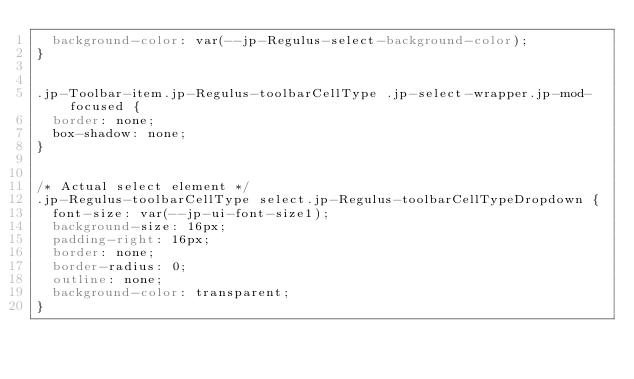<code> <loc_0><loc_0><loc_500><loc_500><_CSS_>  background-color: var(--jp-Regulus-select-background-color);
}


.jp-Toolbar-item.jp-Regulus-toolbarCellType .jp-select-wrapper.jp-mod-focused {
  border: none;
  box-shadow: none;
}


/* Actual select element */
.jp-Regulus-toolbarCellType select.jp-Regulus-toolbarCellTypeDropdown {
  font-size: var(--jp-ui-font-size1);
  background-size: 16px;
  padding-right: 16px;
  border: none;
  border-radius: 0;
  outline: none;
  background-color: transparent;
}
</code> 